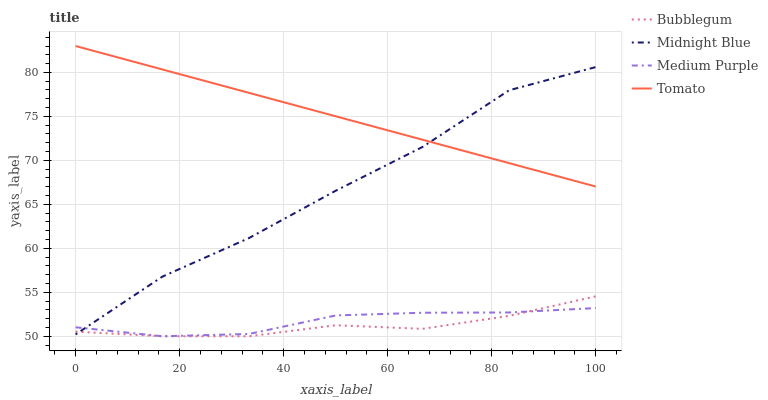Does Bubblegum have the minimum area under the curve?
Answer yes or no. Yes. Does Tomato have the maximum area under the curve?
Answer yes or no. Yes. Does Midnight Blue have the minimum area under the curve?
Answer yes or no. No. Does Midnight Blue have the maximum area under the curve?
Answer yes or no. No. Is Tomato the smoothest?
Answer yes or no. Yes. Is Midnight Blue the roughest?
Answer yes or no. Yes. Is Midnight Blue the smoothest?
Answer yes or no. No. Is Tomato the roughest?
Answer yes or no. No. Does Medium Purple have the lowest value?
Answer yes or no. Yes. Does Midnight Blue have the lowest value?
Answer yes or no. No. Does Tomato have the highest value?
Answer yes or no. Yes. Does Midnight Blue have the highest value?
Answer yes or no. No. Is Bubblegum less than Tomato?
Answer yes or no. Yes. Is Tomato greater than Bubblegum?
Answer yes or no. Yes. Does Bubblegum intersect Midnight Blue?
Answer yes or no. Yes. Is Bubblegum less than Midnight Blue?
Answer yes or no. No. Is Bubblegum greater than Midnight Blue?
Answer yes or no. No. Does Bubblegum intersect Tomato?
Answer yes or no. No. 